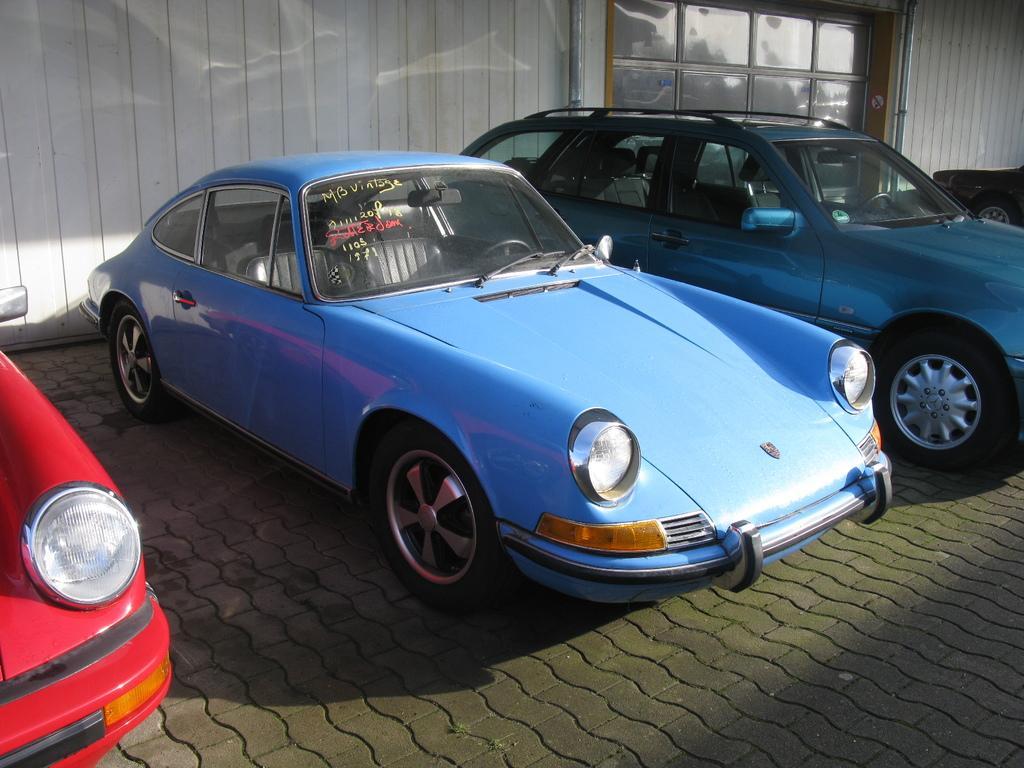How would you summarize this image in a sentence or two? In this picture we can see vehicles on the ground and in the background we can see an object, wall. 